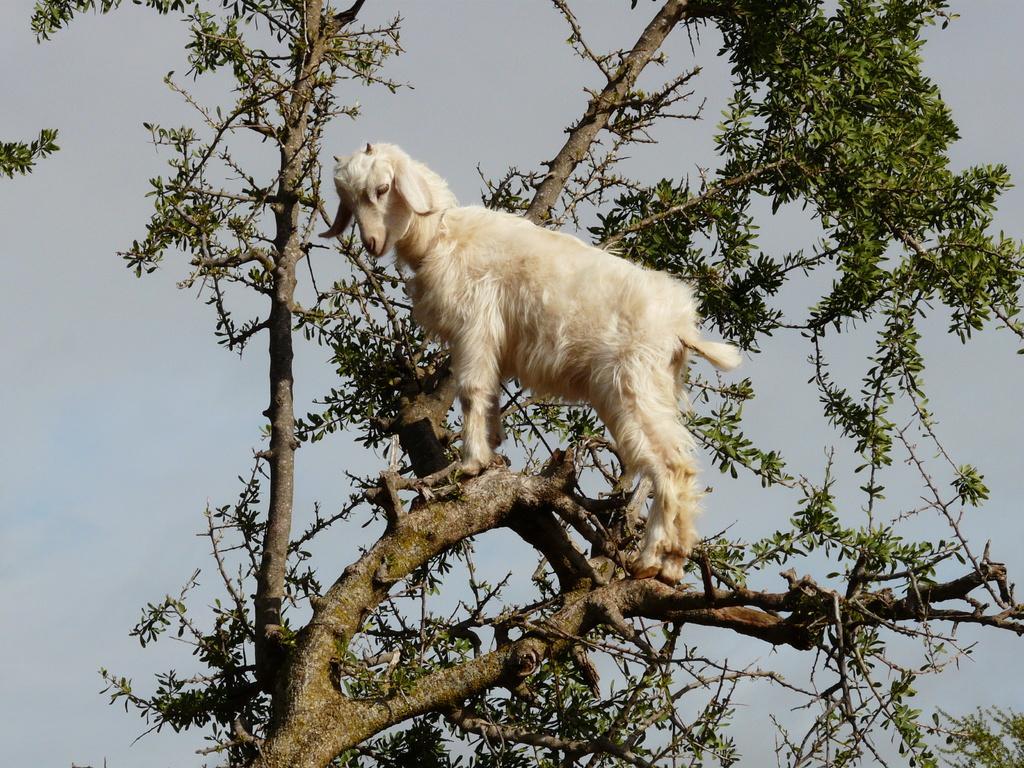In one or two sentences, can you explain what this image depicts? In the picture I can see a tree and there is a goat on the branch of a tree. There are clouds in the sky. 